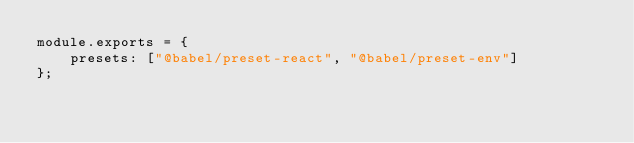Convert code to text. <code><loc_0><loc_0><loc_500><loc_500><_JavaScript_>module.exports = {
    presets: ["@babel/preset-react", "@babel/preset-env"]
};</code> 